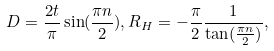Convert formula to latex. <formula><loc_0><loc_0><loc_500><loc_500>D = \frac { 2 t } { \pi } \sin ( \frac { \pi n } { 2 } ) , R _ { H } = - \frac { \pi } { 2 } \frac { 1 } { \tan ( \frac { \pi n } { 2 } ) } ,</formula> 